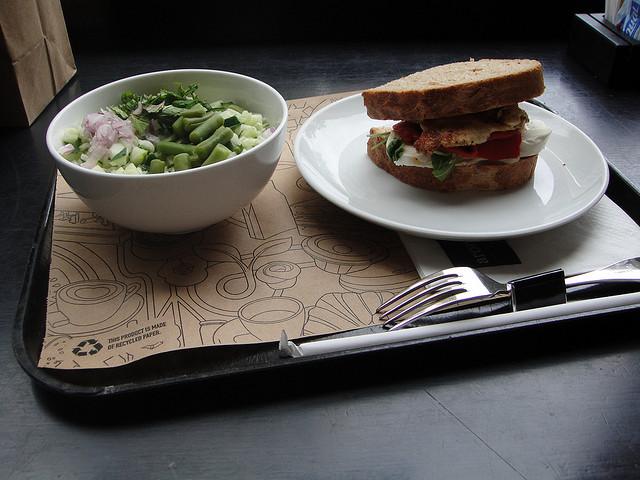What food dish is on the plate?
Concise answer only. Sandwich. What color is the bowl on the platter?
Keep it brief. White. What vegetable is in the bowl?
Give a very brief answer. Green beans. What type of bowl's are there?
Be succinct. Ceramic. Is the bowl empty?
Concise answer only. No. What is the fork made of?
Keep it brief. Metal. IS there a spoon?
Short answer required. No. Is the color yellow in the image?
Write a very short answer. No. Is this food served in a home?
Write a very short answer. No. What animal is depicted on the placemat?
Write a very short answer. None. Is this for breakfast?
Write a very short answer. No. What material is the table made from?
Concise answer only. Wood. What is the colorful paper next to the fork?
Short answer required. Napkin. 